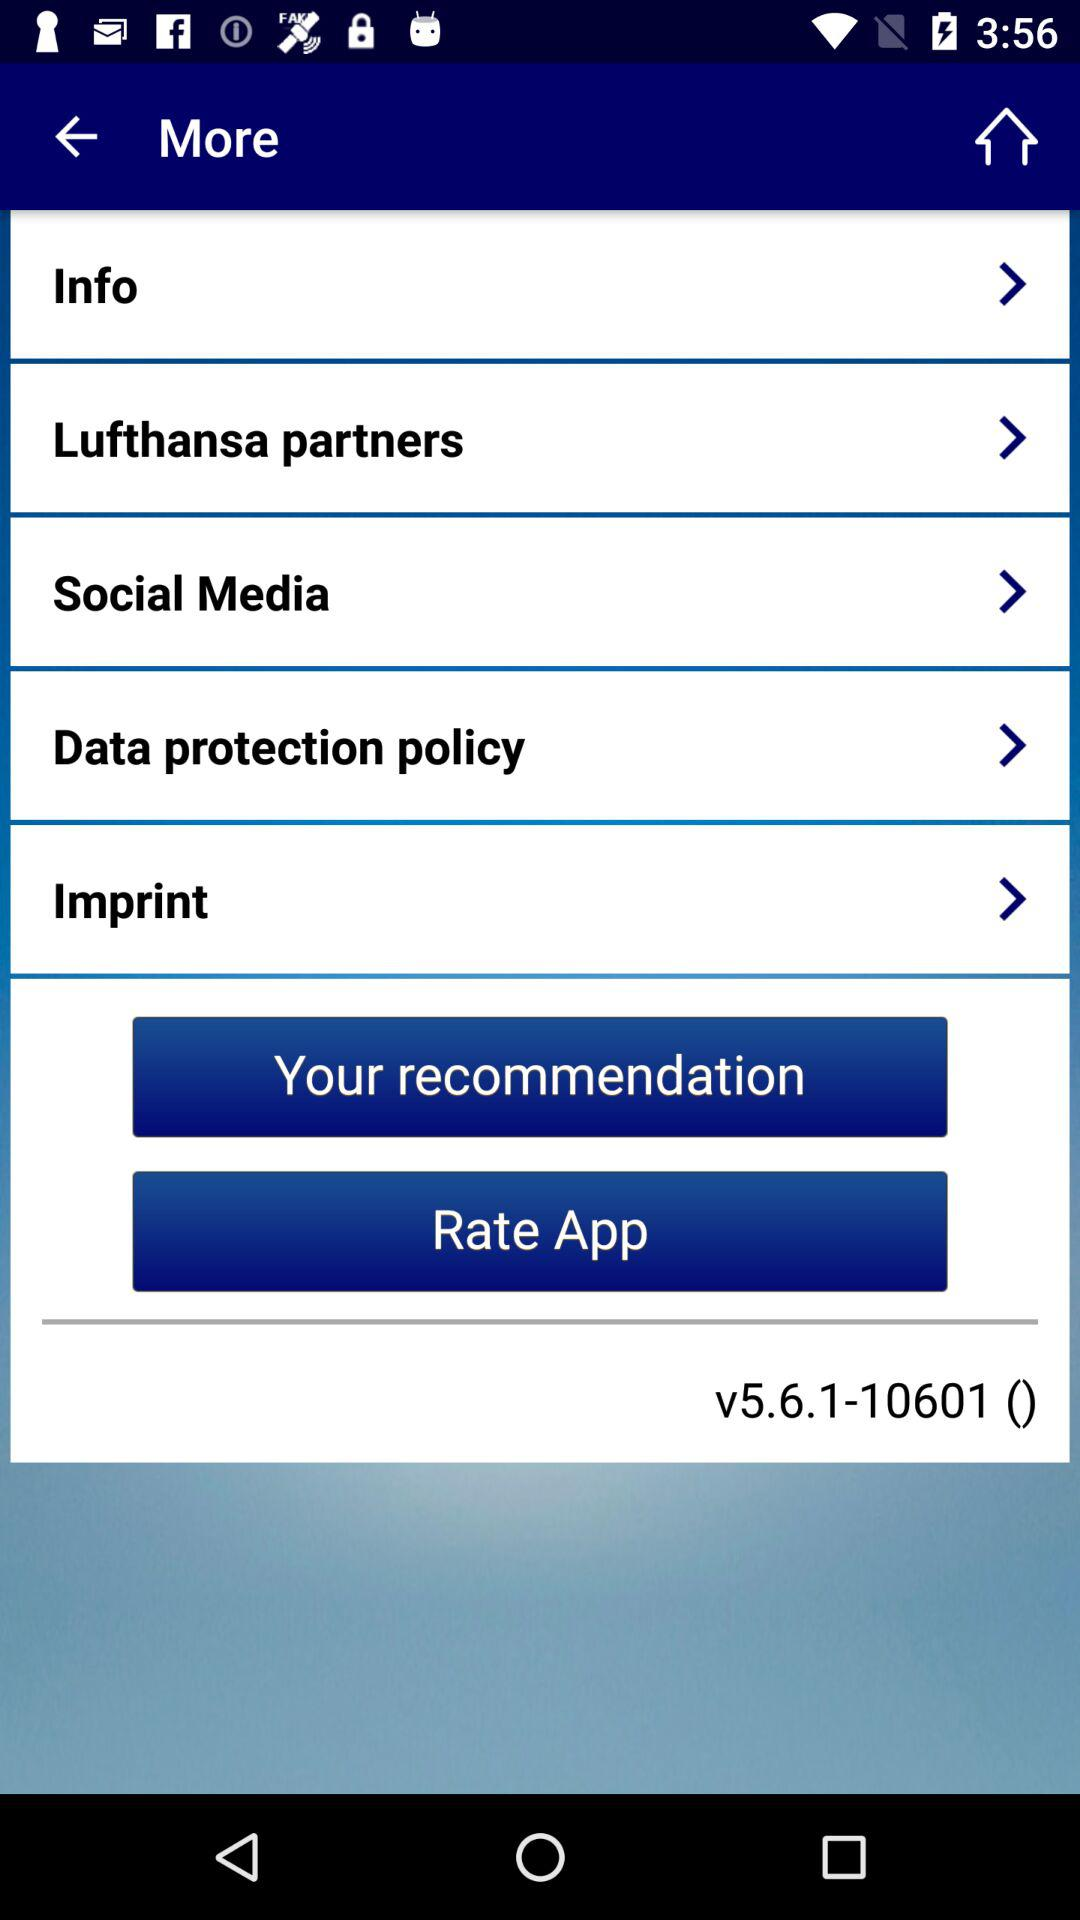What is the version of the application being used? The version of the application is v5.6.1-10601. 